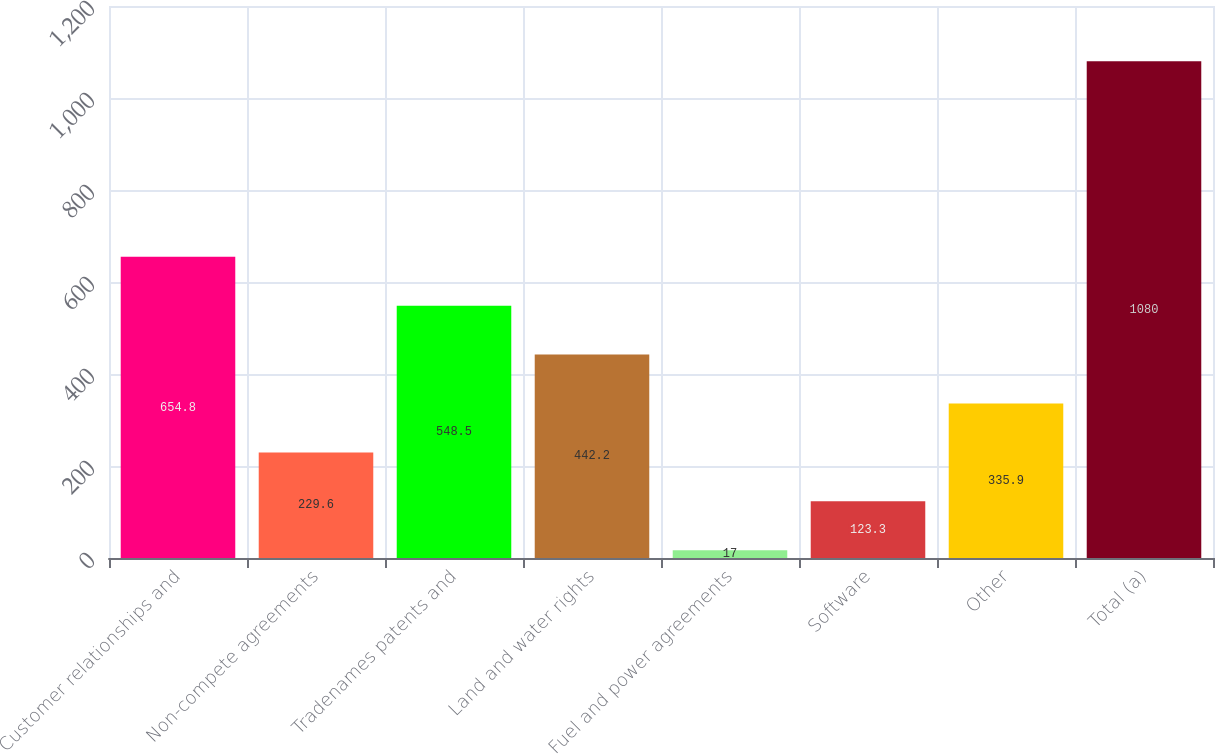Convert chart. <chart><loc_0><loc_0><loc_500><loc_500><bar_chart><fcel>Customer relationships and<fcel>Non-compete agreements<fcel>Tradenames patents and<fcel>Land and water rights<fcel>Fuel and power agreements<fcel>Software<fcel>Other<fcel>Total (a)<nl><fcel>654.8<fcel>229.6<fcel>548.5<fcel>442.2<fcel>17<fcel>123.3<fcel>335.9<fcel>1080<nl></chart> 